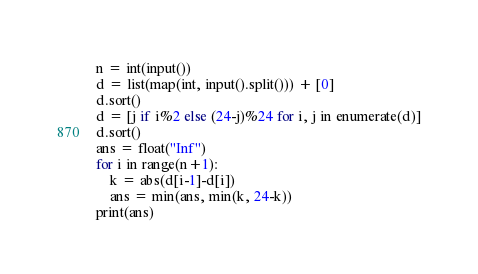Convert code to text. <code><loc_0><loc_0><loc_500><loc_500><_Python_>n = int(input())
d = list(map(int, input().split())) + [0]
d.sort()
d = [j if i%2 else (24-j)%24 for i, j in enumerate(d)]
d.sort()
ans = float("Inf")
for i in range(n+1):
    k = abs(d[i-1]-d[i])
    ans = min(ans, min(k, 24-k))
print(ans)</code> 